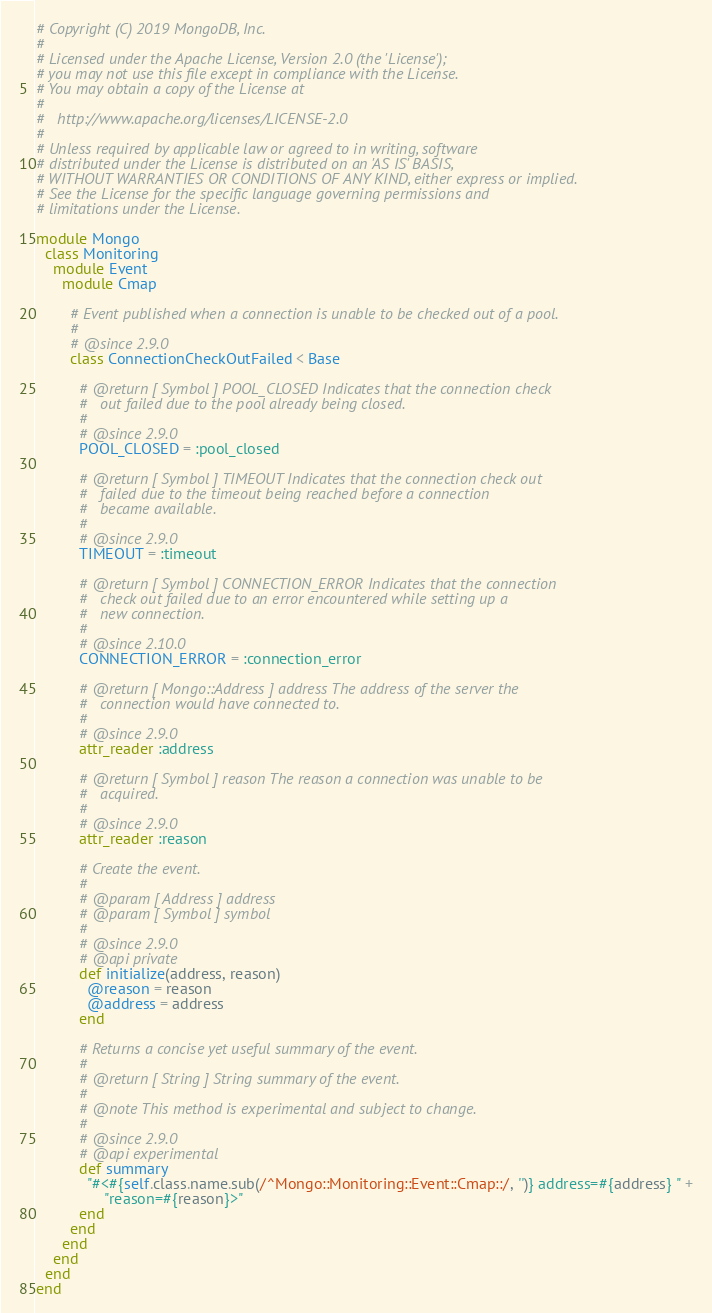Convert code to text. <code><loc_0><loc_0><loc_500><loc_500><_Ruby_># Copyright (C) 2019 MongoDB, Inc.
#
# Licensed under the Apache License, Version 2.0 (the 'License');
# you may not use this file except in compliance with the License.
# You may obtain a copy of the License at
#
#   http://www.apache.org/licenses/LICENSE-2.0
#
# Unless required by applicable law or agreed to in writing, software
# distributed under the License is distributed on an 'AS IS' BASIS,
# WITHOUT WARRANTIES OR CONDITIONS OF ANY KIND, either express or implied.
# See the License for the specific language governing permissions and
# limitations under the License.

module Mongo
  class Monitoring
    module Event
      module Cmap

        # Event published when a connection is unable to be checked out of a pool.
        #
        # @since 2.9.0
        class ConnectionCheckOutFailed < Base

          # @return [ Symbol ] POOL_CLOSED Indicates that the connection check
          #   out failed due to the pool already being closed.
          #
          # @since 2.9.0
          POOL_CLOSED = :pool_closed

          # @return [ Symbol ] TIMEOUT Indicates that the connection check out
          #   failed due to the timeout being reached before a connection
          #   became available.
          #
          # @since 2.9.0
          TIMEOUT = :timeout

          # @return [ Symbol ] CONNECTION_ERROR Indicates that the connection
          #   check out failed due to an error encountered while setting up a
          #   new connection.
          #
          # @since 2.10.0
          CONNECTION_ERROR = :connection_error

          # @return [ Mongo::Address ] address The address of the server the
          #   connection would have connected to.
          #
          # @since 2.9.0
          attr_reader :address

          # @return [ Symbol ] reason The reason a connection was unable to be
          #   acquired.
          #
          # @since 2.9.0
          attr_reader :reason

          # Create the event.
          #
          # @param [ Address ] address
          # @param [ Symbol ] symbol
          #
          # @since 2.9.0
          # @api private
          def initialize(address, reason)
            @reason = reason
            @address = address
          end

          # Returns a concise yet useful summary of the event.
          #
          # @return [ String ] String summary of the event.
          #
          # @note This method is experimental and subject to change.
          #
          # @since 2.9.0
          # @api experimental
          def summary
            "#<#{self.class.name.sub(/^Mongo::Monitoring::Event::Cmap::/, '')} address=#{address} " +
                "reason=#{reason}>"
          end
        end
      end
    end
  end
end
</code> 